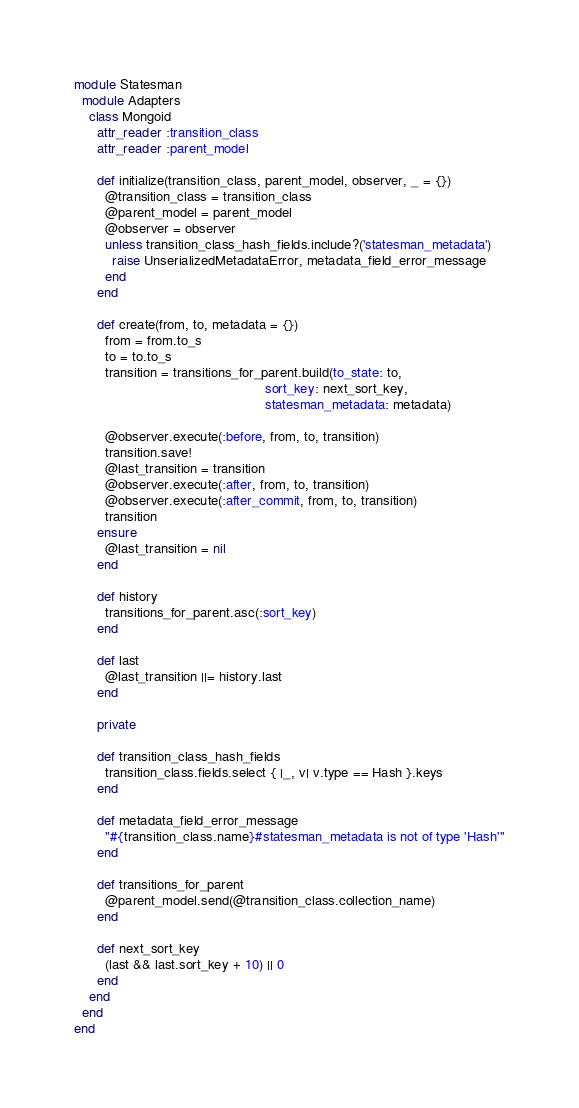Convert code to text. <code><loc_0><loc_0><loc_500><loc_500><_Ruby_>
module Statesman
  module Adapters
    class Mongoid
      attr_reader :transition_class
      attr_reader :parent_model

      def initialize(transition_class, parent_model, observer, _ = {})
        @transition_class = transition_class
        @parent_model = parent_model
        @observer = observer
        unless transition_class_hash_fields.include?('statesman_metadata')
          raise UnserializedMetadataError, metadata_field_error_message
        end
      end

      def create(from, to, metadata = {})
        from = from.to_s
        to = to.to_s
        transition = transitions_for_parent.build(to_state: to,
                                                  sort_key: next_sort_key,
                                                  statesman_metadata: metadata)

        @observer.execute(:before, from, to, transition)
        transition.save!
        @last_transition = transition
        @observer.execute(:after, from, to, transition)
        @observer.execute(:after_commit, from, to, transition)
        transition
      ensure
        @last_transition = nil
      end

      def history
        transitions_for_parent.asc(:sort_key)
      end

      def last
        @last_transition ||= history.last
      end

      private

      def transition_class_hash_fields
        transition_class.fields.select { |_, v| v.type == Hash }.keys
      end

      def metadata_field_error_message
        "#{transition_class.name}#statesman_metadata is not of type 'Hash'"
      end

      def transitions_for_parent
        @parent_model.send(@transition_class.collection_name)
      end

      def next_sort_key
        (last && last.sort_key + 10) || 0
      end
    end
  end
end
</code> 